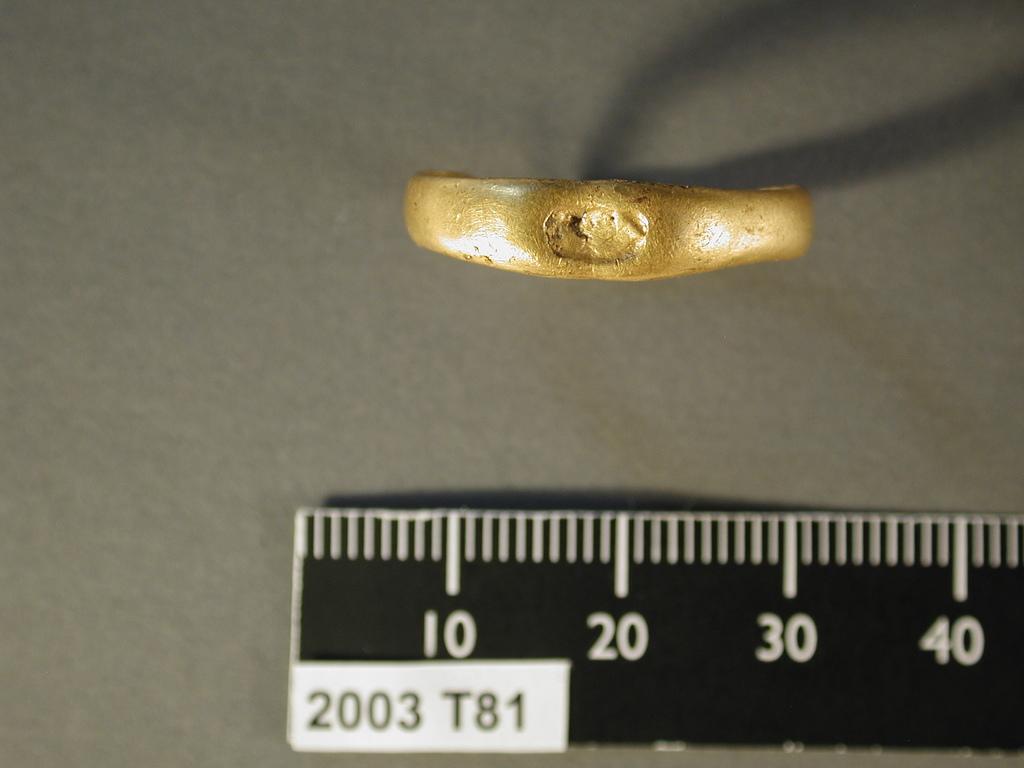What is the first measurement increment?
Your answer should be compact. 10. What year is on the white label?
Provide a succinct answer. 2003. 